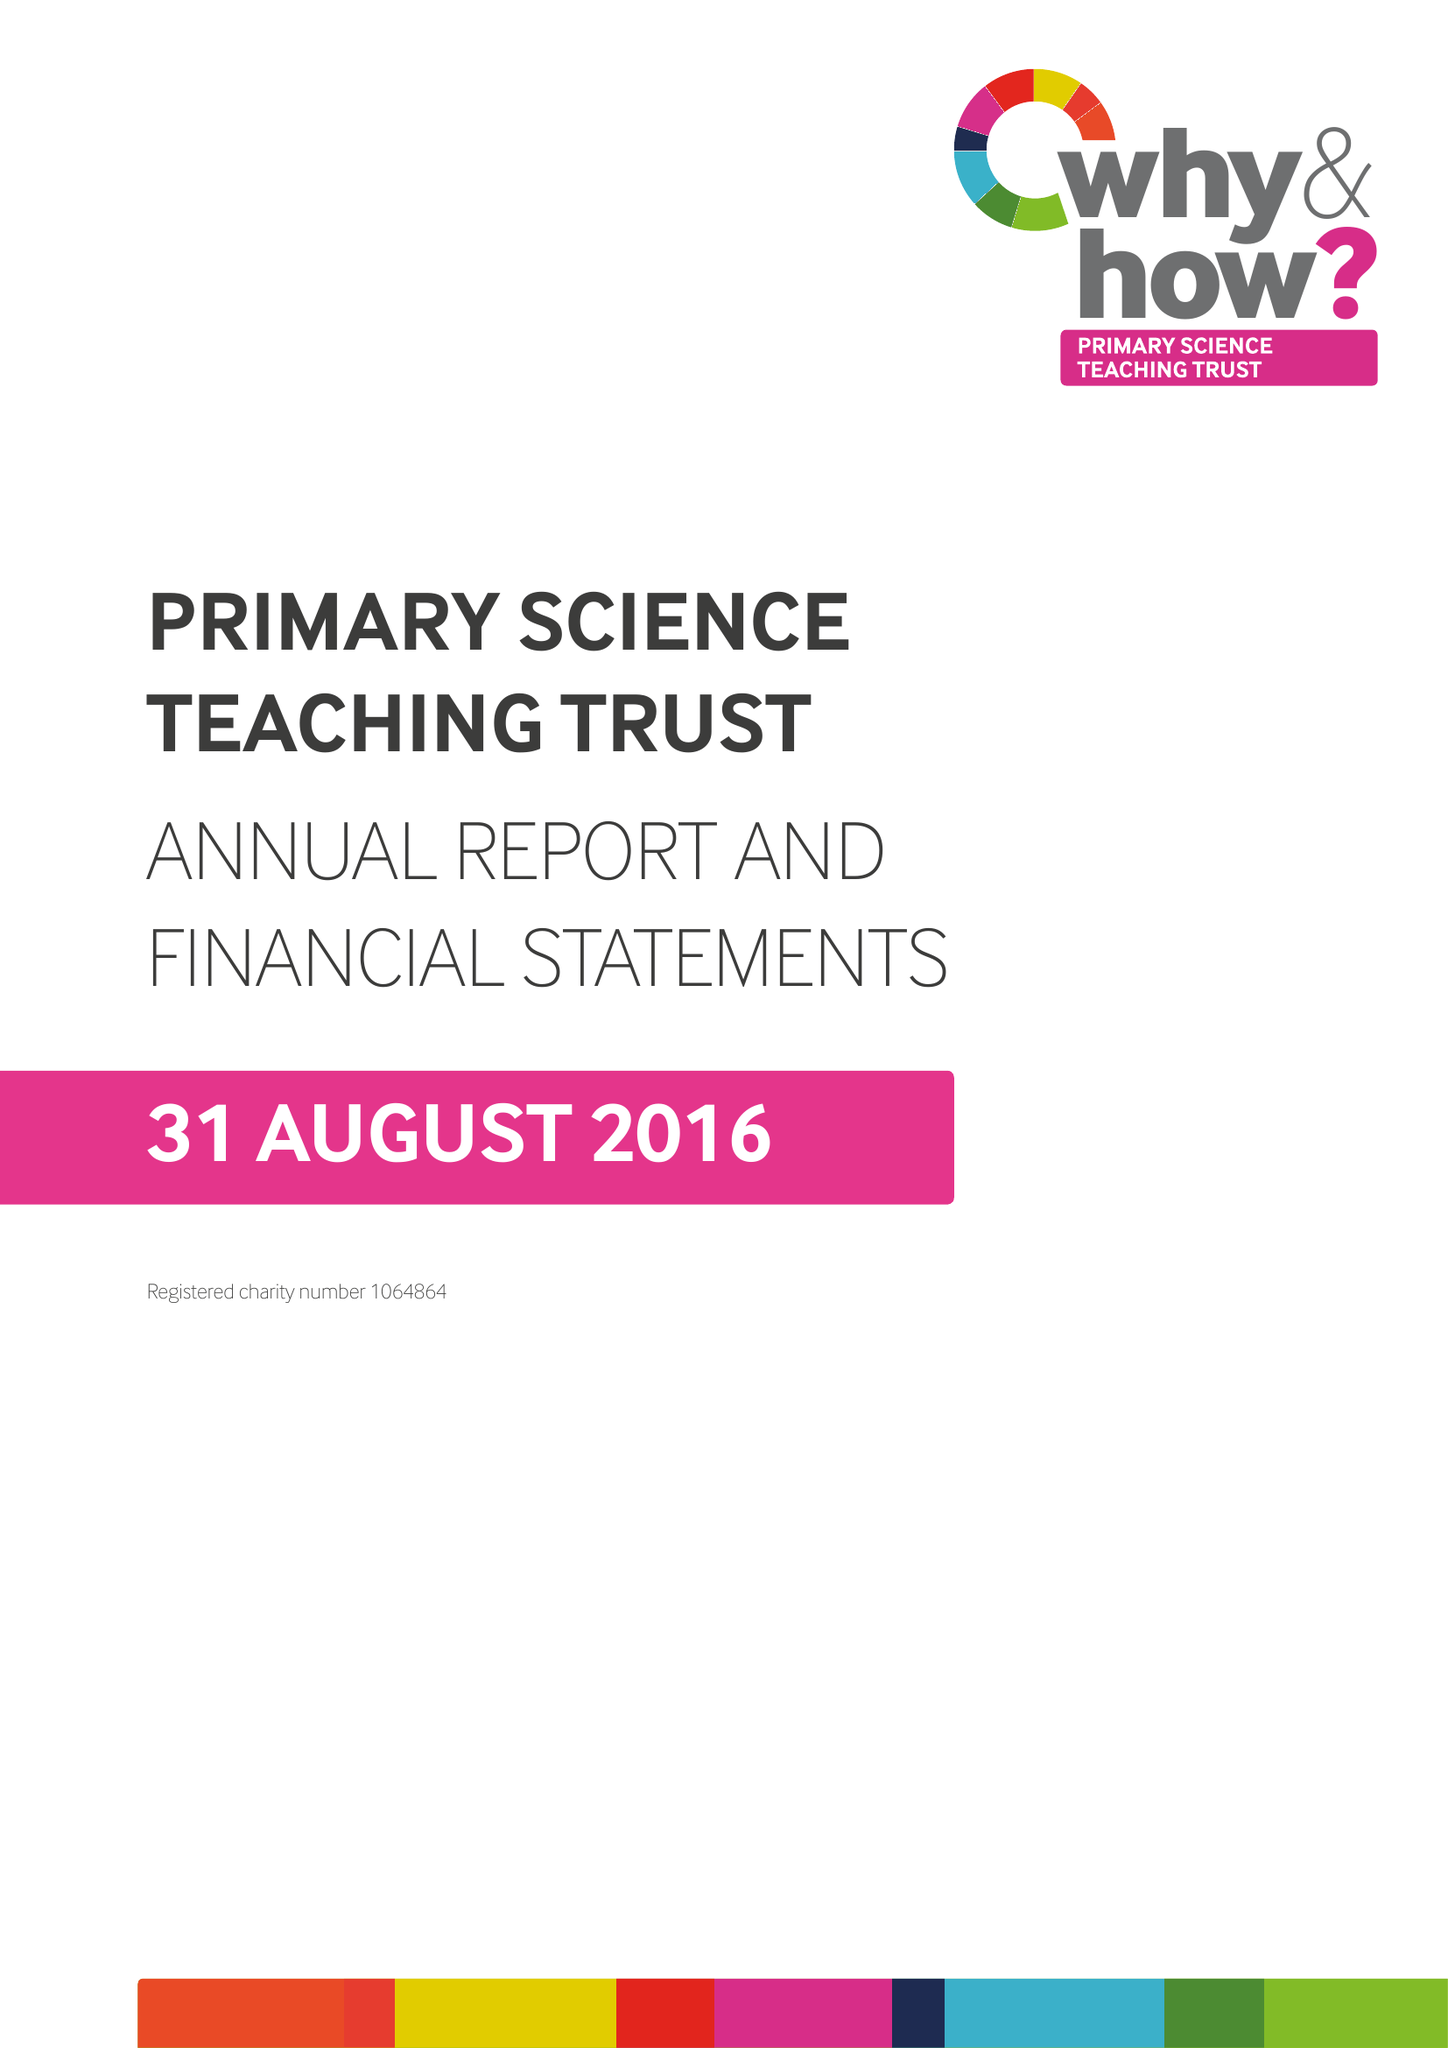What is the value for the charity_name?
Answer the question using a single word or phrase. Primary Science Teaching Trust 